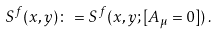<formula> <loc_0><loc_0><loc_500><loc_500>S ^ { f } ( x , y ) \colon = S ^ { f } ( x , y ; [ A _ { \mu } = 0 ] ) \, .</formula> 